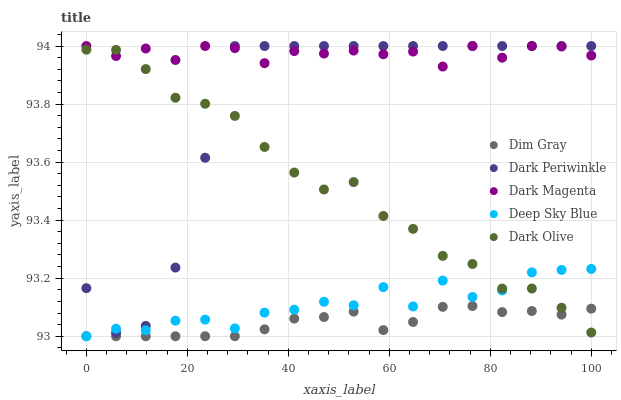Does Dim Gray have the minimum area under the curve?
Answer yes or no. Yes. Does Dark Magenta have the maximum area under the curve?
Answer yes or no. Yes. Does Dark Periwinkle have the minimum area under the curve?
Answer yes or no. No. Does Dark Periwinkle have the maximum area under the curve?
Answer yes or no. No. Is Dim Gray the smoothest?
Answer yes or no. Yes. Is Deep Sky Blue the roughest?
Answer yes or no. Yes. Is Dark Periwinkle the smoothest?
Answer yes or no. No. Is Dark Periwinkle the roughest?
Answer yes or no. No. Does Dim Gray have the lowest value?
Answer yes or no. Yes. Does Dark Periwinkle have the lowest value?
Answer yes or no. No. Does Dark Magenta have the highest value?
Answer yes or no. Yes. Does Dim Gray have the highest value?
Answer yes or no. No. Is Deep Sky Blue less than Dark Magenta?
Answer yes or no. Yes. Is Dark Periwinkle greater than Dim Gray?
Answer yes or no. Yes. Does Deep Sky Blue intersect Dark Periwinkle?
Answer yes or no. Yes. Is Deep Sky Blue less than Dark Periwinkle?
Answer yes or no. No. Is Deep Sky Blue greater than Dark Periwinkle?
Answer yes or no. No. Does Deep Sky Blue intersect Dark Magenta?
Answer yes or no. No. 